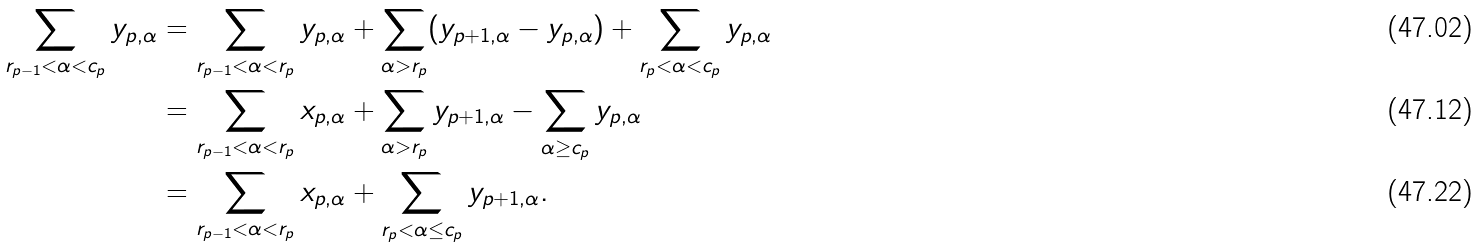Convert formula to latex. <formula><loc_0><loc_0><loc_500><loc_500>\sum _ { r _ { p - 1 } < \alpha < c _ { p } } y _ { p , \alpha } & = \sum _ { r _ { p - 1 } < \alpha < r _ { p } } y _ { p , \alpha } + \sum _ { \alpha > r _ { p } } ( y _ { p + 1 , \alpha } - y _ { p , \alpha } ) + \sum _ { r _ { p } < \alpha < c _ { p } } y _ { p , \alpha } \\ & = \sum _ { r _ { p - 1 } < \alpha < r _ { p } } x _ { p , \alpha } + \sum _ { \alpha > r _ { p } } y _ { p + 1 , \alpha } - \sum _ { \alpha \geq c _ { p } } y _ { p , \alpha } \\ & = \sum _ { r _ { p - 1 } < \alpha < r _ { p } } x _ { p , \alpha } + \sum _ { r _ { p } < \alpha \leq c _ { p } } y _ { p + 1 , \alpha } .</formula> 